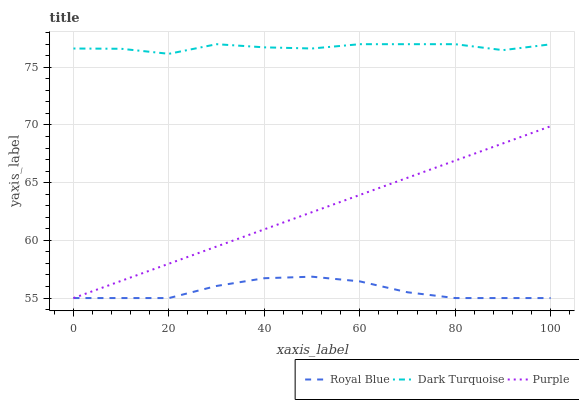Does Royal Blue have the minimum area under the curve?
Answer yes or no. Yes. Does Dark Turquoise have the maximum area under the curve?
Answer yes or no. Yes. Does Dark Turquoise have the minimum area under the curve?
Answer yes or no. No. Does Royal Blue have the maximum area under the curve?
Answer yes or no. No. Is Purple the smoothest?
Answer yes or no. Yes. Is Dark Turquoise the roughest?
Answer yes or no. Yes. Is Royal Blue the smoothest?
Answer yes or no. No. Is Royal Blue the roughest?
Answer yes or no. No. Does Purple have the lowest value?
Answer yes or no. Yes. Does Dark Turquoise have the lowest value?
Answer yes or no. No. Does Dark Turquoise have the highest value?
Answer yes or no. Yes. Does Royal Blue have the highest value?
Answer yes or no. No. Is Royal Blue less than Dark Turquoise?
Answer yes or no. Yes. Is Dark Turquoise greater than Purple?
Answer yes or no. Yes. Does Royal Blue intersect Purple?
Answer yes or no. Yes. Is Royal Blue less than Purple?
Answer yes or no. No. Is Royal Blue greater than Purple?
Answer yes or no. No. Does Royal Blue intersect Dark Turquoise?
Answer yes or no. No. 